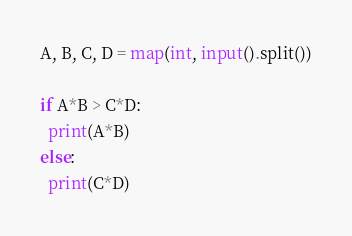<code> <loc_0><loc_0><loc_500><loc_500><_Python_>A, B, C, D = map(int, input().split())

if A*B > C*D:
  print(A*B)
else:
  print(C*D)</code> 